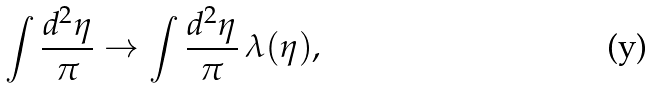<formula> <loc_0><loc_0><loc_500><loc_500>\int \frac { d ^ { 2 } \eta } { \pi } \rightarrow \int \frac { d ^ { 2 } \eta } { \pi } \, \lambda ( \eta ) ,</formula> 